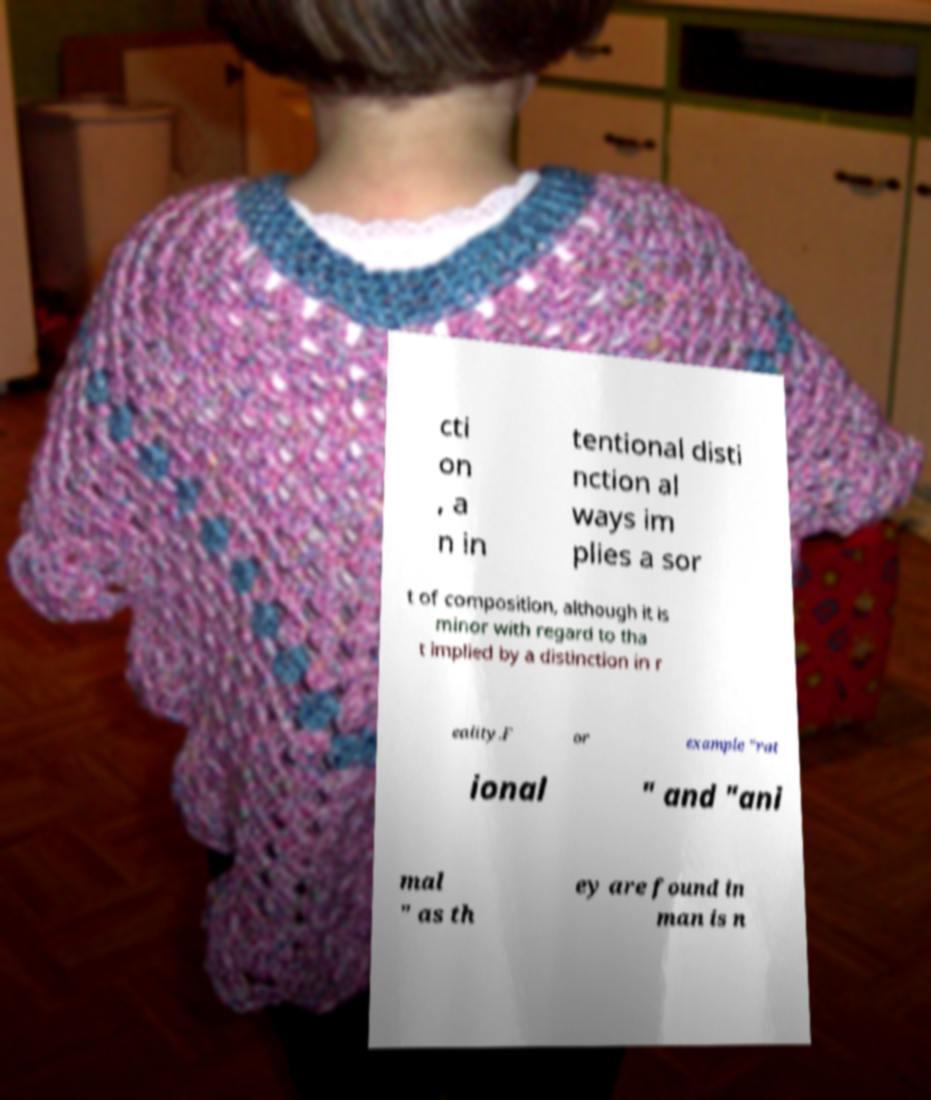I need the written content from this picture converted into text. Can you do that? cti on , a n in tentional disti nction al ways im plies a sor t of composition, although it is minor with regard to tha t implied by a distinction in r eality.F or example "rat ional " and "ani mal " as th ey are found in man is n 